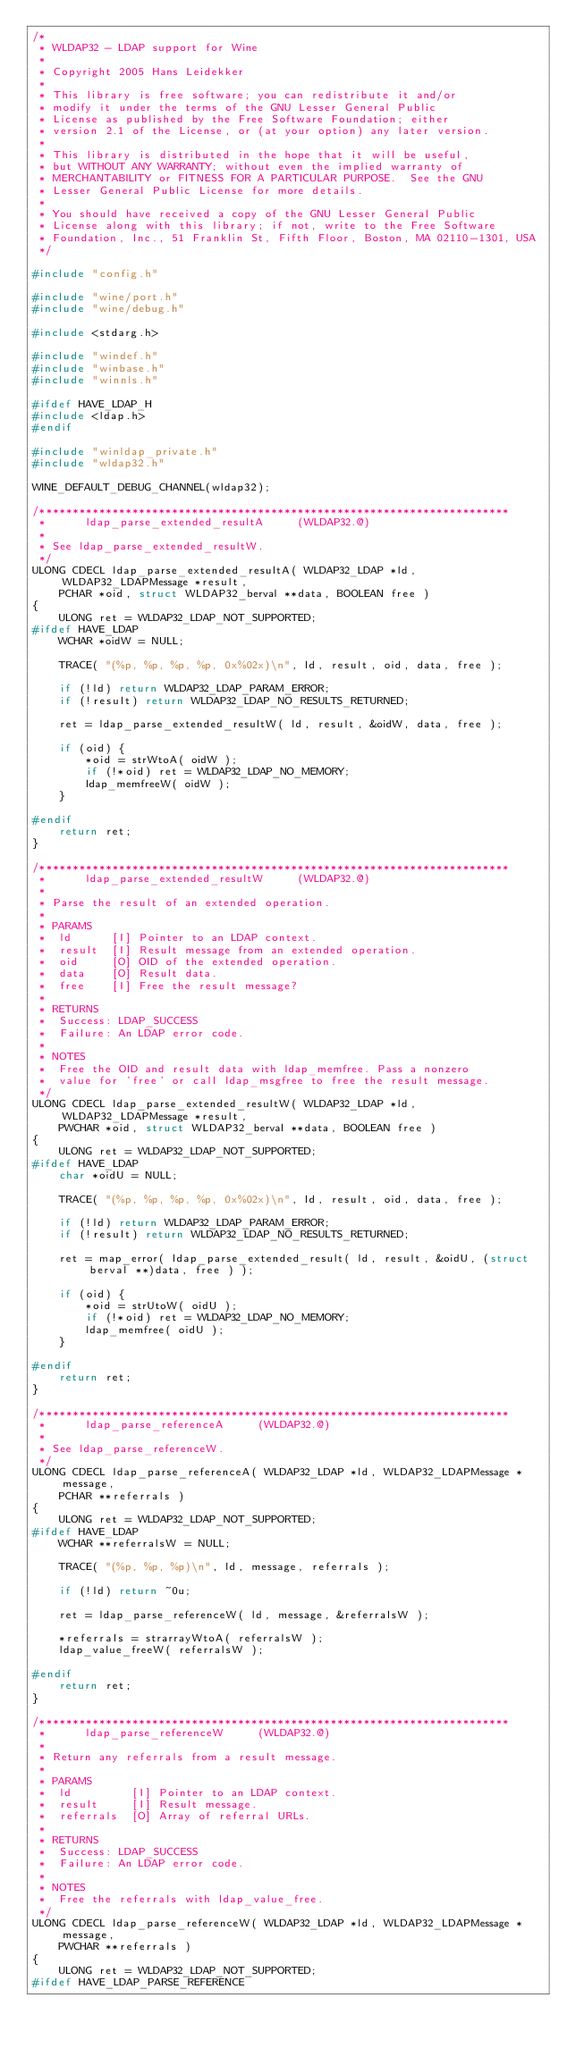<code> <loc_0><loc_0><loc_500><loc_500><_C_>/*
 * WLDAP32 - LDAP support for Wine
 *
 * Copyright 2005 Hans Leidekker
 *
 * This library is free software; you can redistribute it and/or
 * modify it under the terms of the GNU Lesser General Public
 * License as published by the Free Software Foundation; either
 * version 2.1 of the License, or (at your option) any later version.
 *
 * This library is distributed in the hope that it will be useful,
 * but WITHOUT ANY WARRANTY; without even the implied warranty of
 * MERCHANTABILITY or FITNESS FOR A PARTICULAR PURPOSE.  See the GNU
 * Lesser General Public License for more details.
 *
 * You should have received a copy of the GNU Lesser General Public
 * License along with this library; if not, write to the Free Software
 * Foundation, Inc., 51 Franklin St, Fifth Floor, Boston, MA 02110-1301, USA
 */

#include "config.h"

#include "wine/port.h"
#include "wine/debug.h"

#include <stdarg.h>

#include "windef.h"
#include "winbase.h"
#include "winnls.h"

#ifdef HAVE_LDAP_H
#include <ldap.h>
#endif

#include "winldap_private.h"
#include "wldap32.h"

WINE_DEFAULT_DEBUG_CHANNEL(wldap32);

/***********************************************************************
 *      ldap_parse_extended_resultA     (WLDAP32.@)
 *
 * See ldap_parse_extended_resultW.
 */
ULONG CDECL ldap_parse_extended_resultA( WLDAP32_LDAP *ld, WLDAP32_LDAPMessage *result,
    PCHAR *oid, struct WLDAP32_berval **data, BOOLEAN free )
{
    ULONG ret = WLDAP32_LDAP_NOT_SUPPORTED;
#ifdef HAVE_LDAP
    WCHAR *oidW = NULL;

    TRACE( "(%p, %p, %p, %p, 0x%02x)\n", ld, result, oid, data, free );

    if (!ld) return WLDAP32_LDAP_PARAM_ERROR;
    if (!result) return WLDAP32_LDAP_NO_RESULTS_RETURNED;

    ret = ldap_parse_extended_resultW( ld, result, &oidW, data, free );

    if (oid) {
        *oid = strWtoA( oidW );
        if (!*oid) ret = WLDAP32_LDAP_NO_MEMORY;
        ldap_memfreeW( oidW );
    }

#endif
    return ret;
}

/***********************************************************************
 *      ldap_parse_extended_resultW     (WLDAP32.@)
 *
 * Parse the result of an extended operation. 
 *
 * PARAMS
 *  ld      [I] Pointer to an LDAP context.
 *  result  [I] Result message from an extended operation.
 *  oid     [O] OID of the extended operation.
 *  data    [O] Result data.
 *  free    [I] Free the result message?
 *
 * RETURNS
 *  Success: LDAP_SUCCESS
 *  Failure: An LDAP error code.
 *
 * NOTES
 *  Free the OID and result data with ldap_memfree. Pass a nonzero
 *  value for 'free' or call ldap_msgfree to free the result message.
 */
ULONG CDECL ldap_parse_extended_resultW( WLDAP32_LDAP *ld, WLDAP32_LDAPMessage *result,
    PWCHAR *oid, struct WLDAP32_berval **data, BOOLEAN free )
{
    ULONG ret = WLDAP32_LDAP_NOT_SUPPORTED;
#ifdef HAVE_LDAP
    char *oidU = NULL;

    TRACE( "(%p, %p, %p, %p, 0x%02x)\n", ld, result, oid, data, free );

    if (!ld) return WLDAP32_LDAP_PARAM_ERROR;
    if (!result) return WLDAP32_LDAP_NO_RESULTS_RETURNED;

    ret = map_error( ldap_parse_extended_result( ld, result, &oidU, (struct berval **)data, free ) );

    if (oid) {
        *oid = strUtoW( oidU );
        if (!*oid) ret = WLDAP32_LDAP_NO_MEMORY;
        ldap_memfree( oidU );
    }

#endif
    return ret;
}

/***********************************************************************
 *      ldap_parse_referenceA     (WLDAP32.@)
 *
 * See ldap_parse_referenceW.
 */
ULONG CDECL ldap_parse_referenceA( WLDAP32_LDAP *ld, WLDAP32_LDAPMessage *message,
    PCHAR **referrals )
{
    ULONG ret = WLDAP32_LDAP_NOT_SUPPORTED;
#ifdef HAVE_LDAP
    WCHAR **referralsW = NULL;

    TRACE( "(%p, %p, %p)\n", ld, message, referrals );

    if (!ld) return ~0u;

    ret = ldap_parse_referenceW( ld, message, &referralsW );

    *referrals = strarrayWtoA( referralsW );
    ldap_value_freeW( referralsW );

#endif 
    return ret;
}

/***********************************************************************
 *      ldap_parse_referenceW     (WLDAP32.@)
 *
 * Return any referrals from a result message.
 *
 * PARAMS
 *  ld         [I] Pointer to an LDAP context.
 *  result     [I] Result message.
 *  referrals  [O] Array of referral URLs.
 *
 * RETURNS
 *  Success: LDAP_SUCCESS
 *  Failure: An LDAP error code.
 *
 * NOTES
 *  Free the referrals with ldap_value_free.
 */
ULONG CDECL ldap_parse_referenceW( WLDAP32_LDAP *ld, WLDAP32_LDAPMessage *message,
    PWCHAR **referrals )
{
    ULONG ret = WLDAP32_LDAP_NOT_SUPPORTED;
#ifdef HAVE_LDAP_PARSE_REFERENCE</code> 